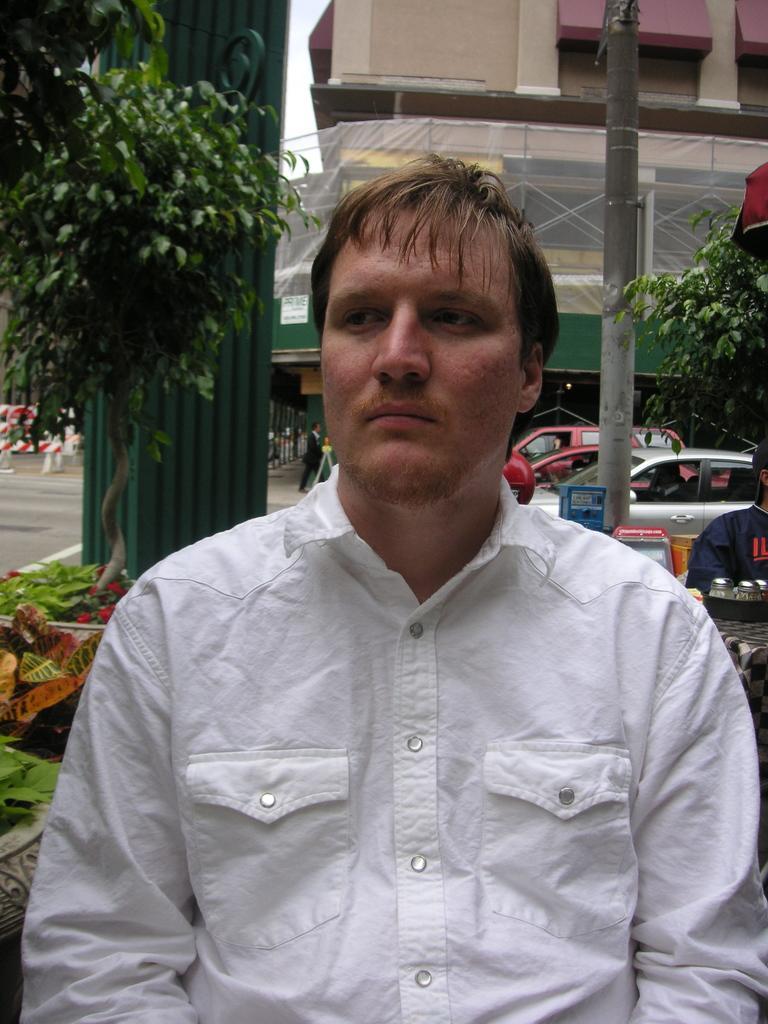In one or two sentences, can you explain what this image depicts? In the image there is a man in white shirt standing in the front and behind there are vehicles on the road with trees on either side and in the background there is a building. 